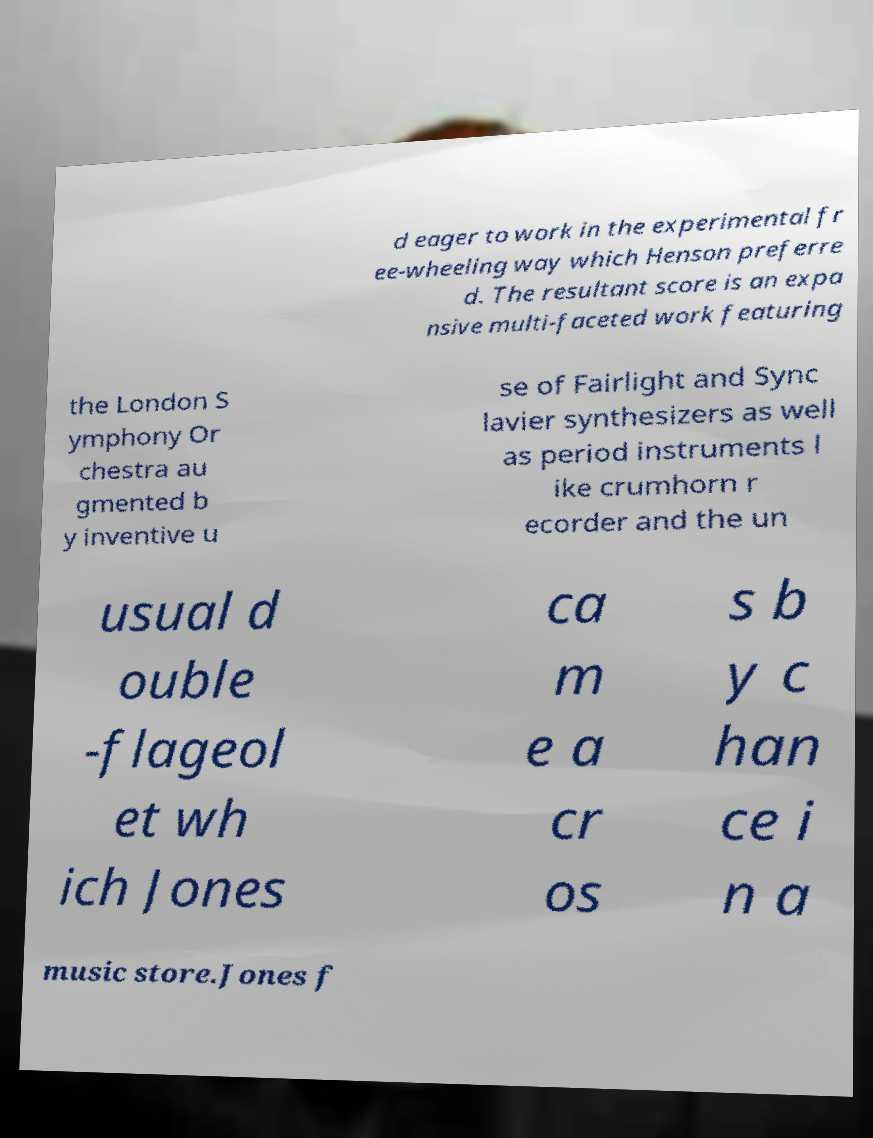For documentation purposes, I need the text within this image transcribed. Could you provide that? d eager to work in the experimental fr ee-wheeling way which Henson preferre d. The resultant score is an expa nsive multi-faceted work featuring the London S ymphony Or chestra au gmented b y inventive u se of Fairlight and Sync lavier synthesizers as well as period instruments l ike crumhorn r ecorder and the un usual d ouble -flageol et wh ich Jones ca m e a cr os s b y c han ce i n a music store.Jones f 